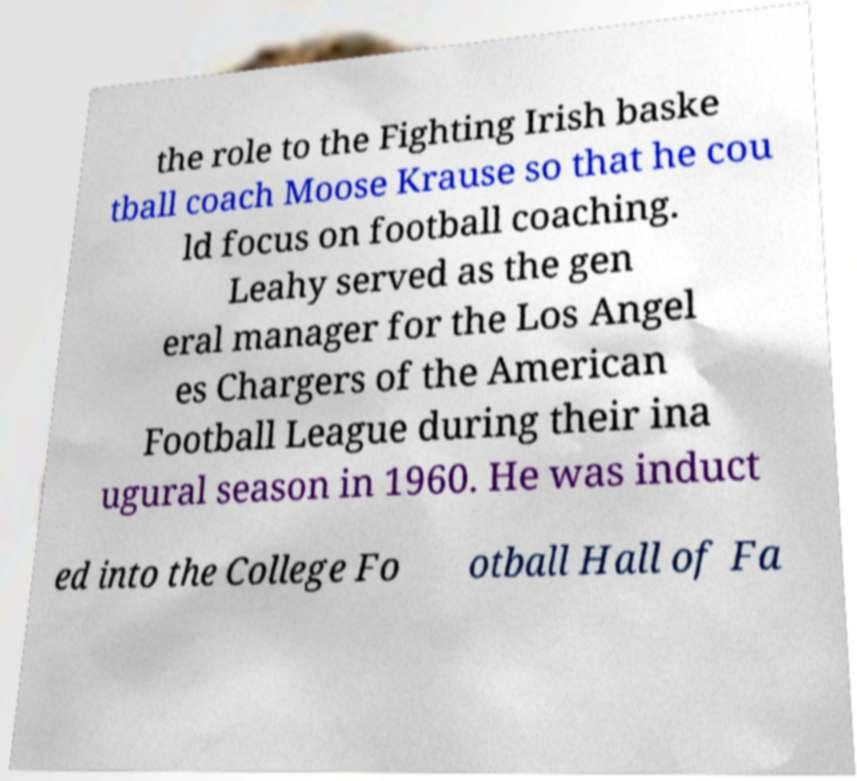Please read and relay the text visible in this image. What does it say? the role to the Fighting Irish baske tball coach Moose Krause so that he cou ld focus on football coaching. Leahy served as the gen eral manager for the Los Angel es Chargers of the American Football League during their ina ugural season in 1960. He was induct ed into the College Fo otball Hall of Fa 